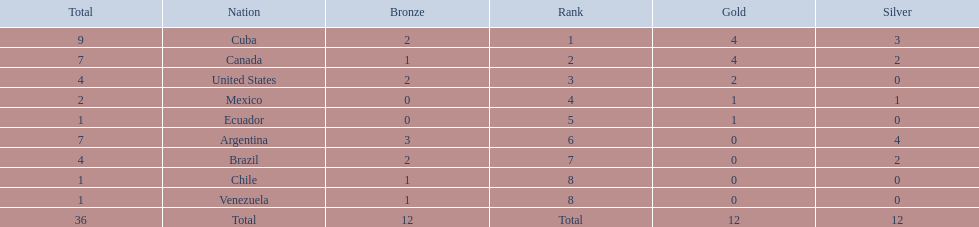Which nations competed in the 2011 pan american games? Cuba, Canada, United States, Mexico, Ecuador, Argentina, Brazil, Chile, Venezuela. Would you be able to parse every entry in this table? {'header': ['Total', 'Nation', 'Bronze', 'Rank', 'Gold', 'Silver'], 'rows': [['9', 'Cuba', '2', '1', '4', '3'], ['7', 'Canada', '1', '2', '4', '2'], ['4', 'United States', '2', '3', '2', '0'], ['2', 'Mexico', '0', '4', '1', '1'], ['1', 'Ecuador', '0', '5', '1', '0'], ['7', 'Argentina', '3', '6', '0', '4'], ['4', 'Brazil', '2', '7', '0', '2'], ['1', 'Chile', '1', '8', '0', '0'], ['1', 'Venezuela', '1', '8', '0', '0'], ['36', 'Total', '12', 'Total', '12', '12']]} Of these nations which ones won gold? Cuba, Canada, United States, Mexico, Ecuador. Which nation of the ones that won gold did not win silver? United States. 